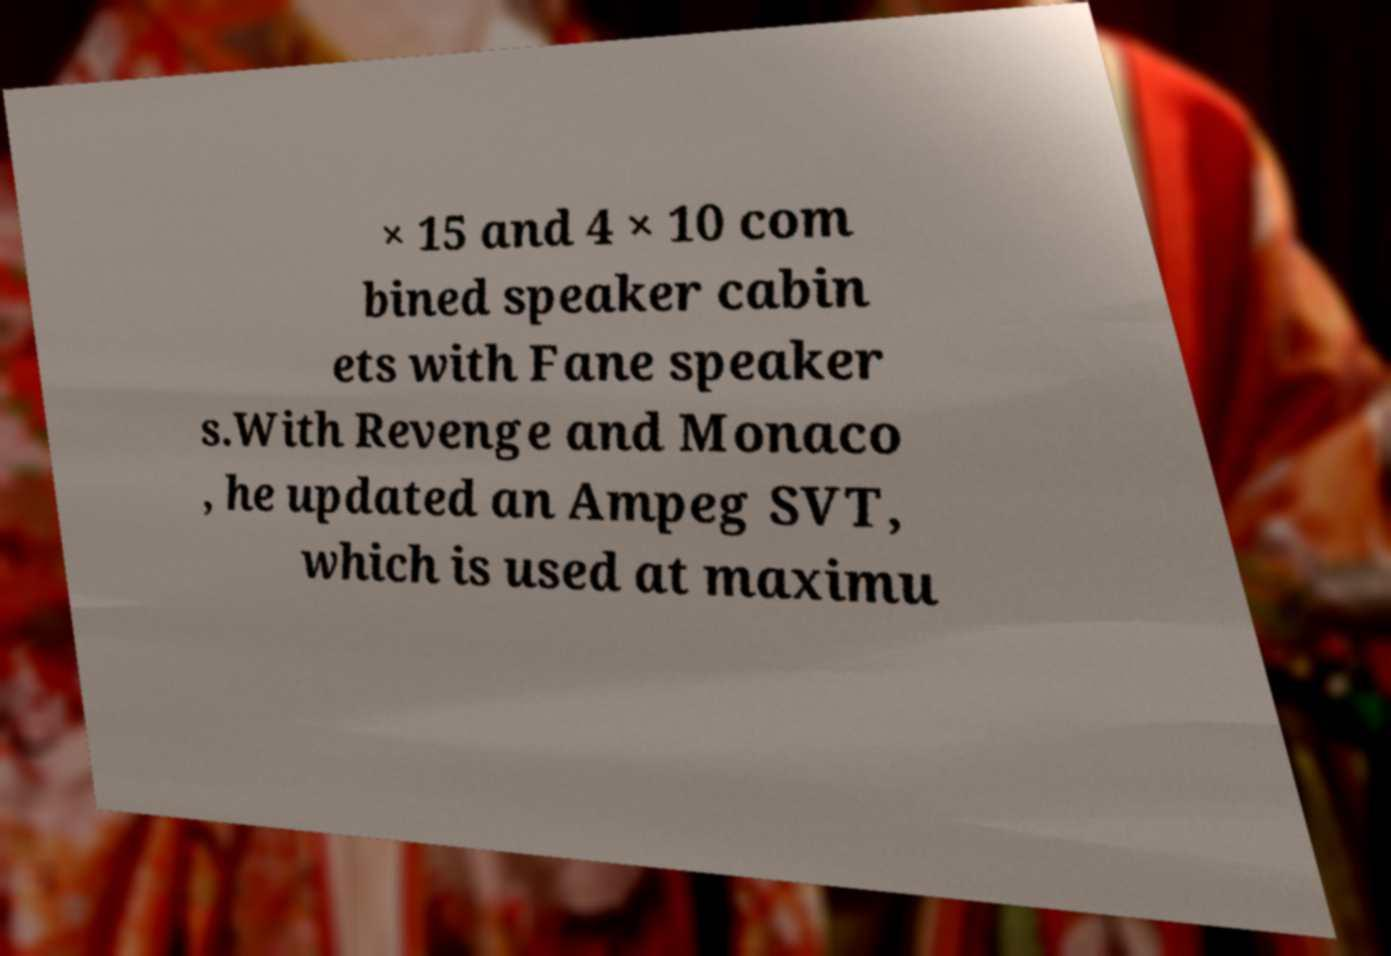Can you read and provide the text displayed in the image?This photo seems to have some interesting text. Can you extract and type it out for me? × 15 and 4 × 10 com bined speaker cabin ets with Fane speaker s.With Revenge and Monaco , he updated an Ampeg SVT, which is used at maximu 